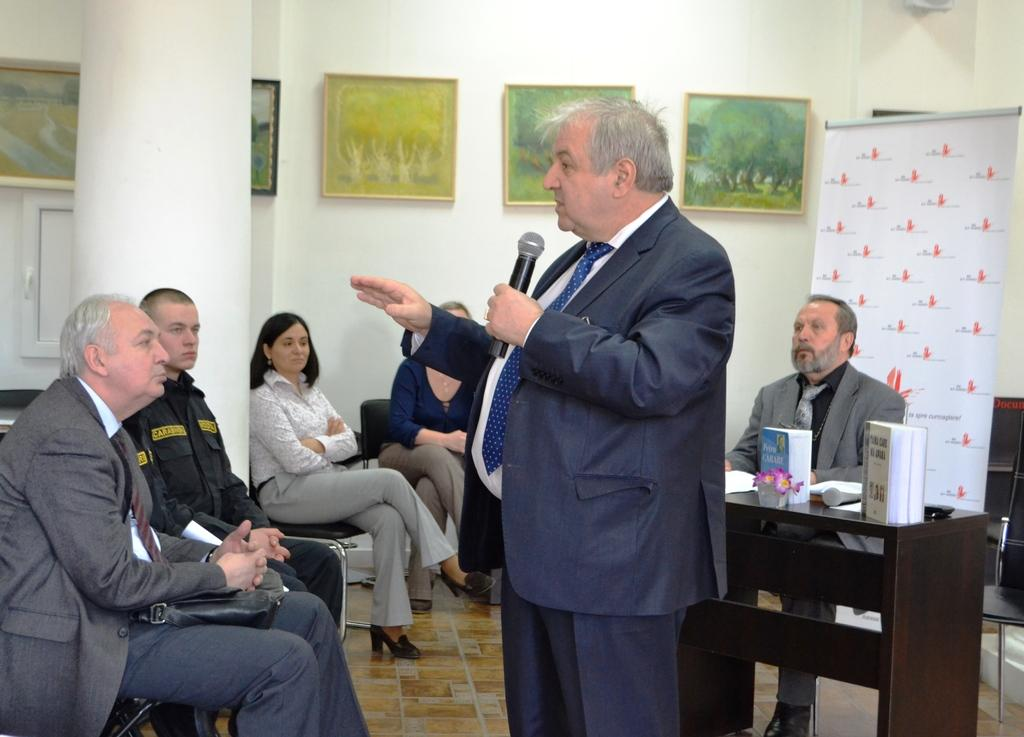What is the man in the image doing? The man is standing and holding a microphone. What are the people in the image doing? The people are sitting and listening to the man. How can you tell that the people are paying attention to the man? The fact that they are sitting and not engaging in other activities suggests that they are listening to the man. What type of cheese is being passed around among the people in the image? There is no cheese present in the image; the people are sitting and listening to the man holding a microphone. 